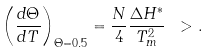Convert formula to latex. <formula><loc_0><loc_0><loc_500><loc_500>\left ( \frac { d \Theta } { d T } \right ) _ { \Theta = 0 . 5 } = \frac { N } { 4 } \frac { \Delta H ^ { * } } { T _ { m } ^ { 2 } } \ > .</formula> 